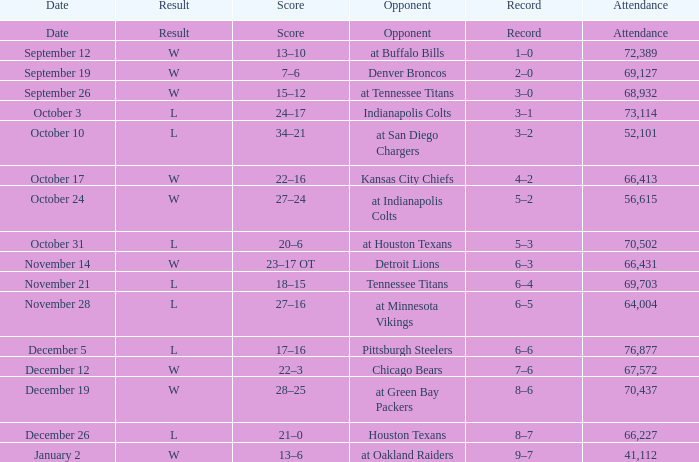What record has w as the result, with January 2 as the date? 9–7. 